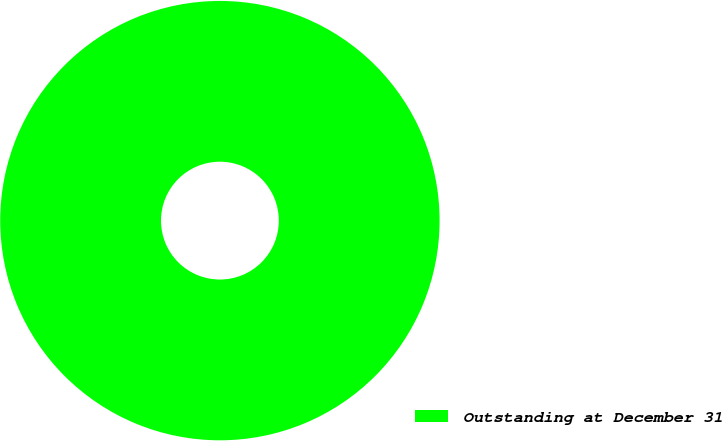Convert chart to OTSL. <chart><loc_0><loc_0><loc_500><loc_500><pie_chart><fcel>Outstanding at December 31<nl><fcel>100.0%<nl></chart> 